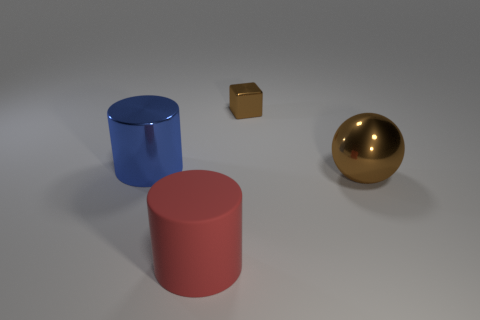Add 3 rubber cylinders. How many objects exist? 7 Subtract 1 cylinders. How many cylinders are left? 1 Subtract 0 gray balls. How many objects are left? 4 Subtract all blocks. How many objects are left? 3 Subtract all purple balls. Subtract all brown blocks. How many balls are left? 1 Subtract all blue shiny things. Subtract all metallic blocks. How many objects are left? 2 Add 4 big metal objects. How many big metal objects are left? 6 Add 1 tiny blue things. How many tiny blue things exist? 1 